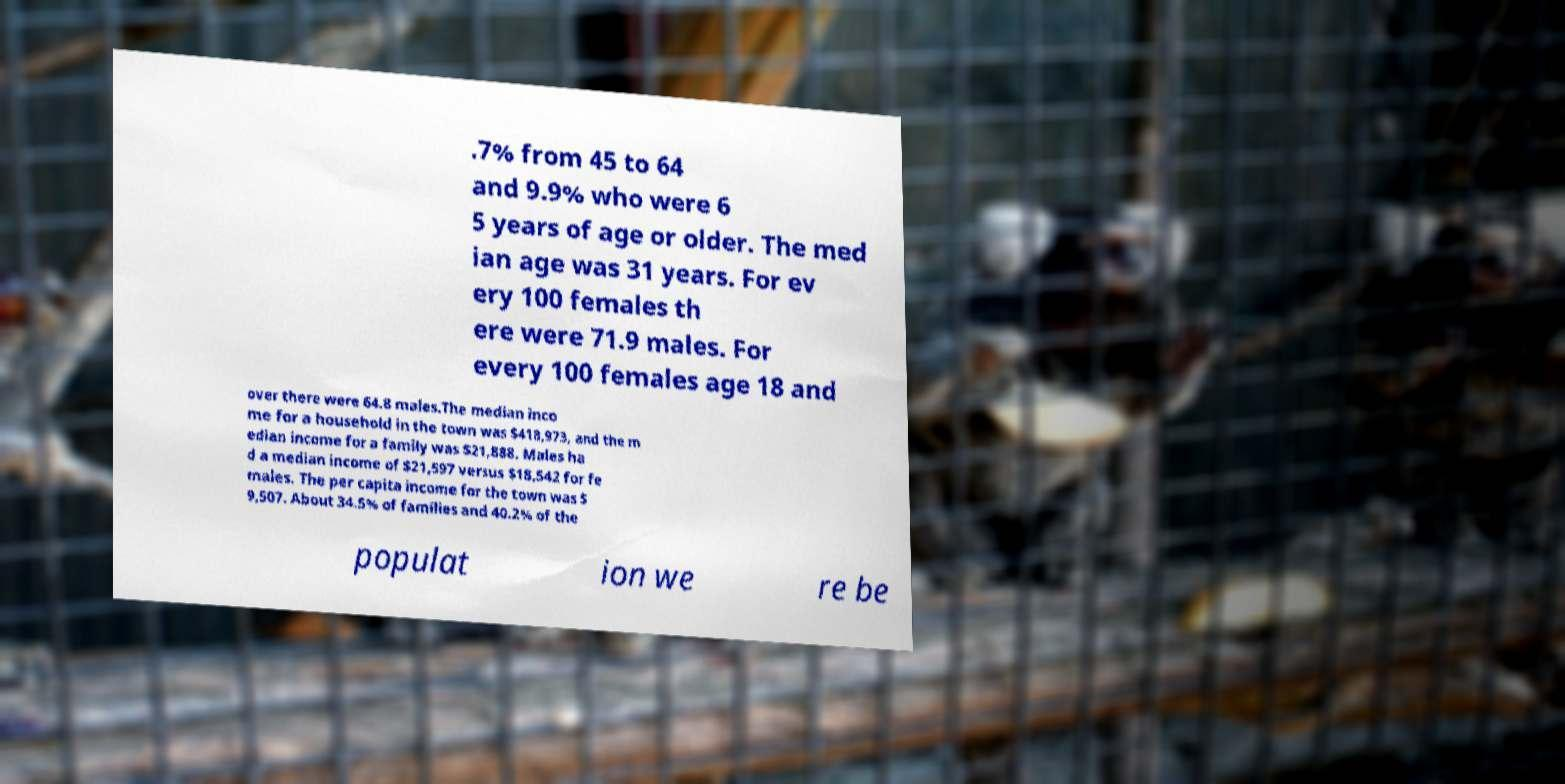I need the written content from this picture converted into text. Can you do that? .7% from 45 to 64 and 9.9% who were 6 5 years of age or older. The med ian age was 31 years. For ev ery 100 females th ere were 71.9 males. For every 100 females age 18 and over there were 64.8 males.The median inco me for a household in the town was $418,973, and the m edian income for a family was $21,888. Males ha d a median income of $21,597 versus $18,542 for fe males. The per capita income for the town was $ 9,507. About 34.5% of families and 40.2% of the populat ion we re be 